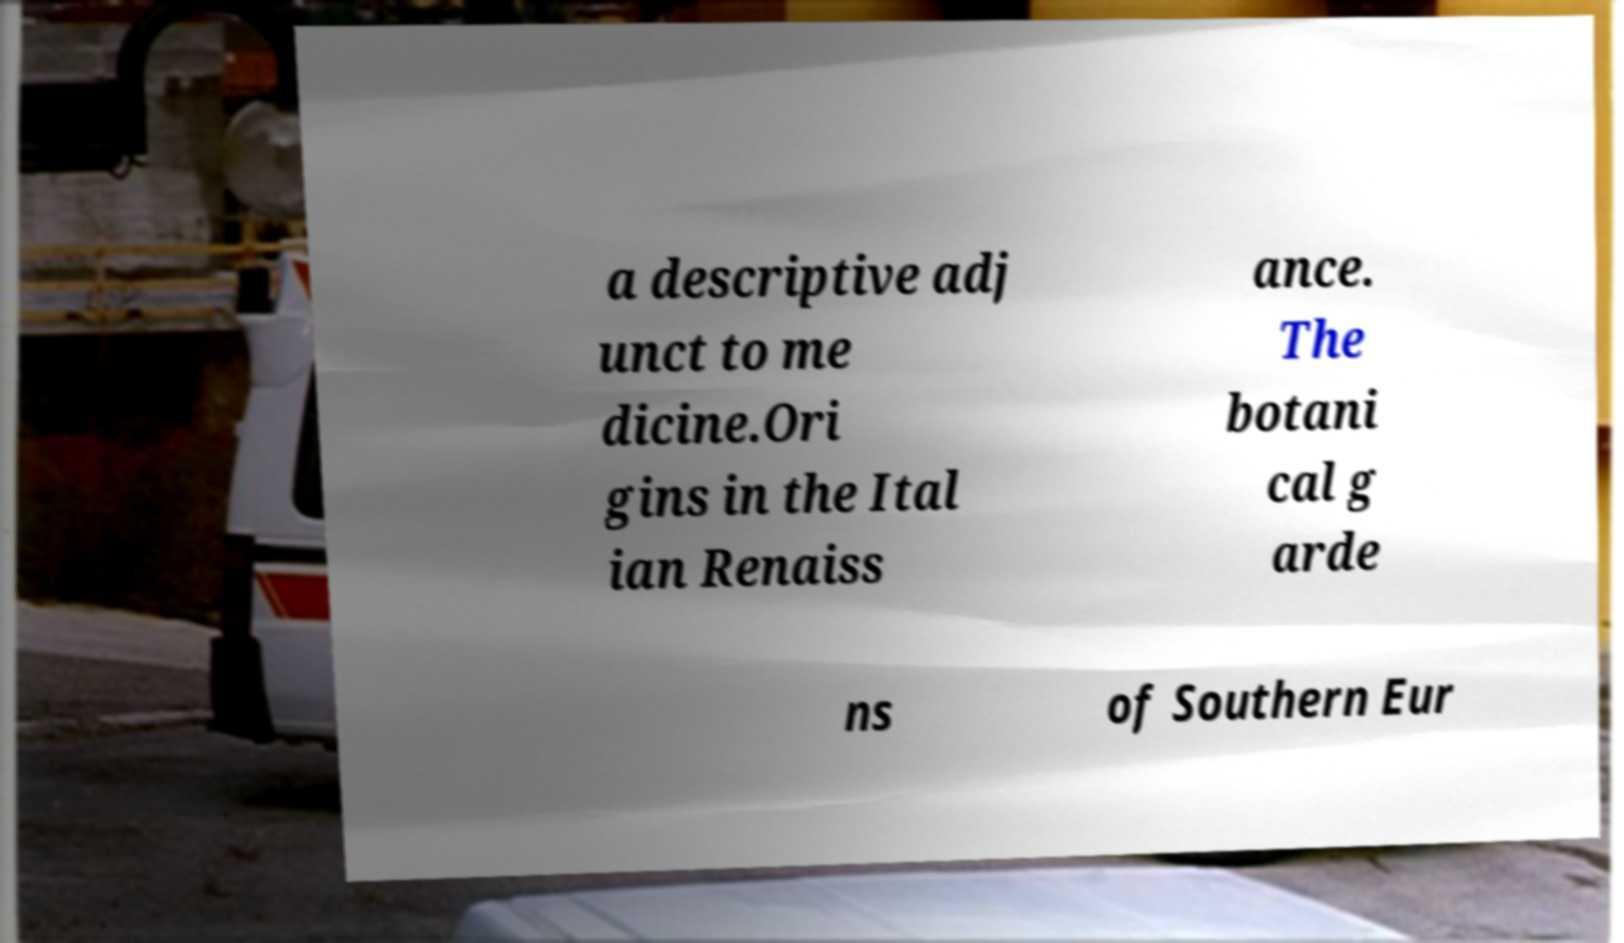Could you extract and type out the text from this image? a descriptive adj unct to me dicine.Ori gins in the Ital ian Renaiss ance. The botani cal g arde ns of Southern Eur 